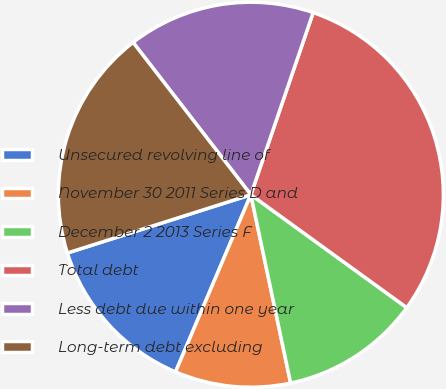Convert chart. <chart><loc_0><loc_0><loc_500><loc_500><pie_chart><fcel>Unsecured revolving line of<fcel>November 30 2011 Series D and<fcel>December 2 2013 Series F<fcel>Total debt<fcel>Less debt due within one year<fcel>Long-term debt excluding<nl><fcel>13.71%<fcel>9.71%<fcel>11.71%<fcel>29.73%<fcel>15.72%<fcel>19.42%<nl></chart> 